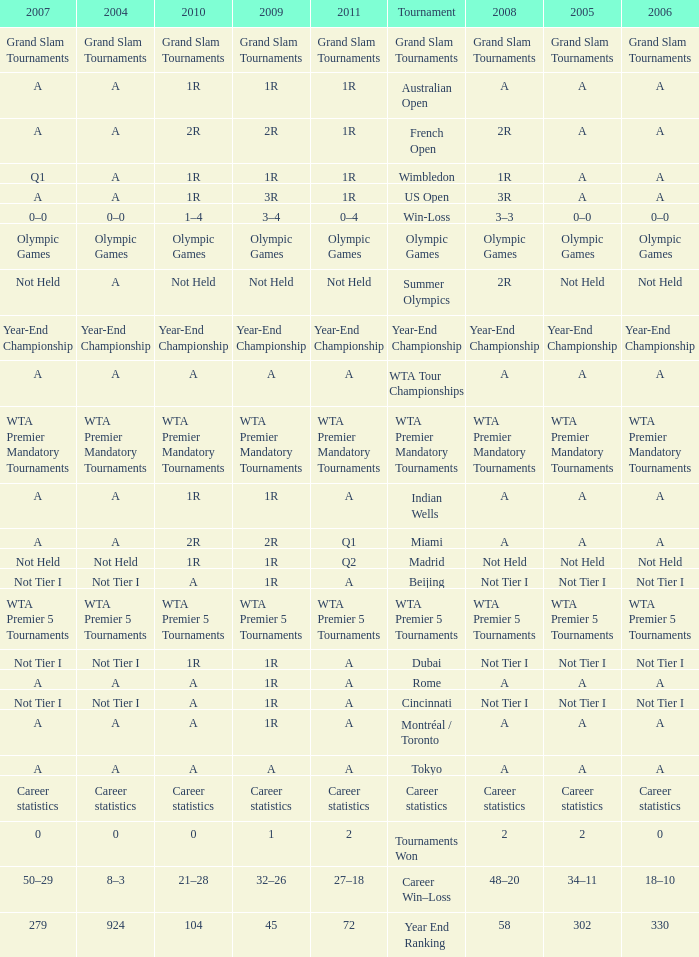Could you parse the entire table? {'header': ['2007', '2004', '2010', '2009', '2011', 'Tournament', '2008', '2005', '2006'], 'rows': [['Grand Slam Tournaments', 'Grand Slam Tournaments', 'Grand Slam Tournaments', 'Grand Slam Tournaments', 'Grand Slam Tournaments', 'Grand Slam Tournaments', 'Grand Slam Tournaments', 'Grand Slam Tournaments', 'Grand Slam Tournaments'], ['A', 'A', '1R', '1R', '1R', 'Australian Open', 'A', 'A', 'A'], ['A', 'A', '2R', '2R', '1R', 'French Open', '2R', 'A', 'A'], ['Q1', 'A', '1R', '1R', '1R', 'Wimbledon', '1R', 'A', 'A'], ['A', 'A', '1R', '3R', '1R', 'US Open', '3R', 'A', 'A'], ['0–0', '0–0', '1–4', '3–4', '0–4', 'Win-Loss', '3–3', '0–0', '0–0'], ['Olympic Games', 'Olympic Games', 'Olympic Games', 'Olympic Games', 'Olympic Games', 'Olympic Games', 'Olympic Games', 'Olympic Games', 'Olympic Games'], ['Not Held', 'A', 'Not Held', 'Not Held', 'Not Held', 'Summer Olympics', '2R', 'Not Held', 'Not Held'], ['Year-End Championship', 'Year-End Championship', 'Year-End Championship', 'Year-End Championship', 'Year-End Championship', 'Year-End Championship', 'Year-End Championship', 'Year-End Championship', 'Year-End Championship'], ['A', 'A', 'A', 'A', 'A', 'WTA Tour Championships', 'A', 'A', 'A'], ['WTA Premier Mandatory Tournaments', 'WTA Premier Mandatory Tournaments', 'WTA Premier Mandatory Tournaments', 'WTA Premier Mandatory Tournaments', 'WTA Premier Mandatory Tournaments', 'WTA Premier Mandatory Tournaments', 'WTA Premier Mandatory Tournaments', 'WTA Premier Mandatory Tournaments', 'WTA Premier Mandatory Tournaments'], ['A', 'A', '1R', '1R', 'A', 'Indian Wells', 'A', 'A', 'A'], ['A', 'A', '2R', '2R', 'Q1', 'Miami', 'A', 'A', 'A'], ['Not Held', 'Not Held', '1R', '1R', 'Q2', 'Madrid', 'Not Held', 'Not Held', 'Not Held'], ['Not Tier I', 'Not Tier I', 'A', '1R', 'A', 'Beijing', 'Not Tier I', 'Not Tier I', 'Not Tier I'], ['WTA Premier 5 Tournaments', 'WTA Premier 5 Tournaments', 'WTA Premier 5 Tournaments', 'WTA Premier 5 Tournaments', 'WTA Premier 5 Tournaments', 'WTA Premier 5 Tournaments', 'WTA Premier 5 Tournaments', 'WTA Premier 5 Tournaments', 'WTA Premier 5 Tournaments'], ['Not Tier I', 'Not Tier I', '1R', '1R', 'A', 'Dubai', 'Not Tier I', 'Not Tier I', 'Not Tier I'], ['A', 'A', 'A', '1R', 'A', 'Rome', 'A', 'A', 'A'], ['Not Tier I', 'Not Tier I', 'A', '1R', 'A', 'Cincinnati', 'Not Tier I', 'Not Tier I', 'Not Tier I'], ['A', 'A', 'A', '1R', 'A', 'Montréal / Toronto', 'A', 'A', 'A'], ['A', 'A', 'A', 'A', 'A', 'Tokyo', 'A', 'A', 'A'], ['Career statistics', 'Career statistics', 'Career statistics', 'Career statistics', 'Career statistics', 'Career statistics', 'Career statistics', 'Career statistics', 'Career statistics'], ['0', '0', '0', '1', '2', 'Tournaments Won', '2', '2', '0'], ['50–29', '8–3', '21–28', '32–26', '27–18', 'Career Win–Loss', '48–20', '34–11', '18–10'], ['279', '924', '104', '45', '72', 'Year End Ranking', '58', '302', '330']]} What is 2011, when 2010 is "WTA Premier 5 Tournaments"? WTA Premier 5 Tournaments. 